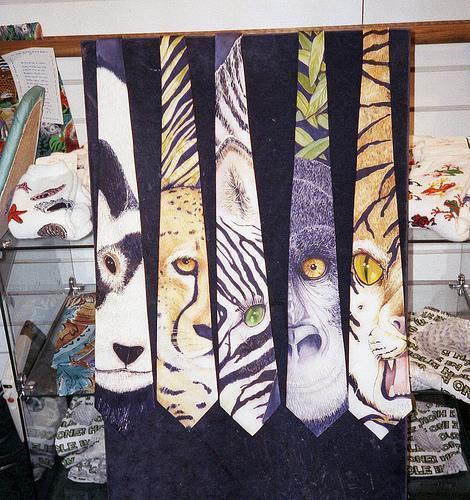How many black ties are there?
Give a very brief answer. 0. 